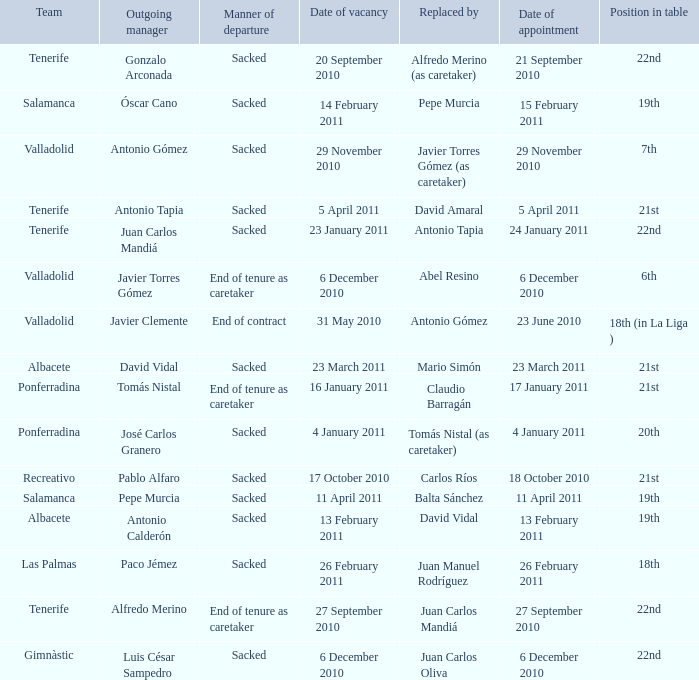Help me parse the entirety of this table. {'header': ['Team', 'Outgoing manager', 'Manner of departure', 'Date of vacancy', 'Replaced by', 'Date of appointment', 'Position in table'], 'rows': [['Tenerife', 'Gonzalo Arconada', 'Sacked', '20 September 2010', 'Alfredo Merino (as caretaker)', '21 September 2010', '22nd'], ['Salamanca', 'Óscar Cano', 'Sacked', '14 February 2011', 'Pepe Murcia', '15 February 2011', '19th'], ['Valladolid', 'Antonio Gómez', 'Sacked', '29 November 2010', 'Javier Torres Gómez (as caretaker)', '29 November 2010', '7th'], ['Tenerife', 'Antonio Tapia', 'Sacked', '5 April 2011', 'David Amaral', '5 April 2011', '21st'], ['Tenerife', 'Juan Carlos Mandiá', 'Sacked', '23 January 2011', 'Antonio Tapia', '24 January 2011', '22nd'], ['Valladolid', 'Javier Torres Gómez', 'End of tenure as caretaker', '6 December 2010', 'Abel Resino', '6 December 2010', '6th'], ['Valladolid', 'Javier Clemente', 'End of contract', '31 May 2010', 'Antonio Gómez', '23 June 2010', '18th (in La Liga )'], ['Albacete', 'David Vidal', 'Sacked', '23 March 2011', 'Mario Simón', '23 March 2011', '21st'], ['Ponferradina', 'Tomás Nistal', 'End of tenure as caretaker', '16 January 2011', 'Claudio Barragán', '17 January 2011', '21st'], ['Ponferradina', 'José Carlos Granero', 'Sacked', '4 January 2011', 'Tomás Nistal (as caretaker)', '4 January 2011', '20th'], ['Recreativo', 'Pablo Alfaro', 'Sacked', '17 October 2010', 'Carlos Ríos', '18 October 2010', '21st'], ['Salamanca', 'Pepe Murcia', 'Sacked', '11 April 2011', 'Balta Sánchez', '11 April 2011', '19th'], ['Albacete', 'Antonio Calderón', 'Sacked', '13 February 2011', 'David Vidal', '13 February 2011', '19th'], ['Las Palmas', 'Paco Jémez', 'Sacked', '26 February 2011', 'Juan Manuel Rodríguez', '26 February 2011', '18th'], ['Tenerife', 'Alfredo Merino', 'End of tenure as caretaker', '27 September 2010', 'Juan Carlos Mandiá', '27 September 2010', '22nd'], ['Gimnàstic', 'Luis César Sampedro', 'Sacked', '6 December 2010', 'Juan Carlos Oliva', '6 December 2010', '22nd']]} How many teams had an outgoing manager of antonio gómez 1.0. 